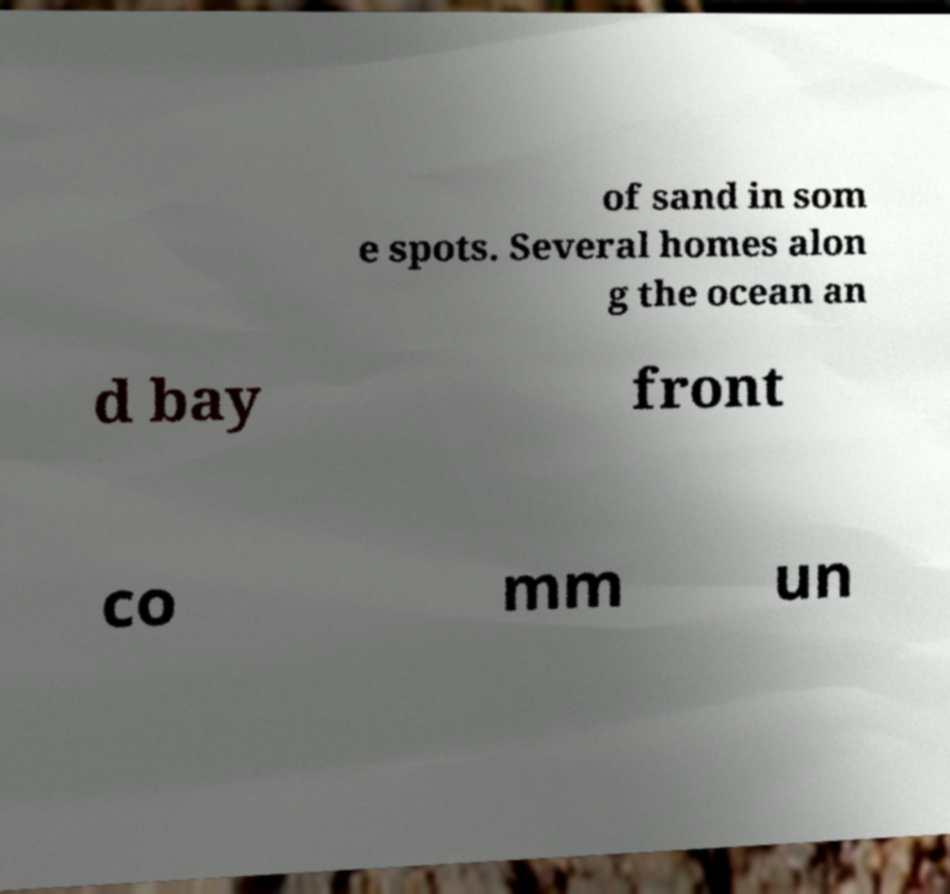For documentation purposes, I need the text within this image transcribed. Could you provide that? of sand in som e spots. Several homes alon g the ocean an d bay front co mm un 